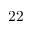Convert formula to latex. <formula><loc_0><loc_0><loc_500><loc_500>2 2</formula> 